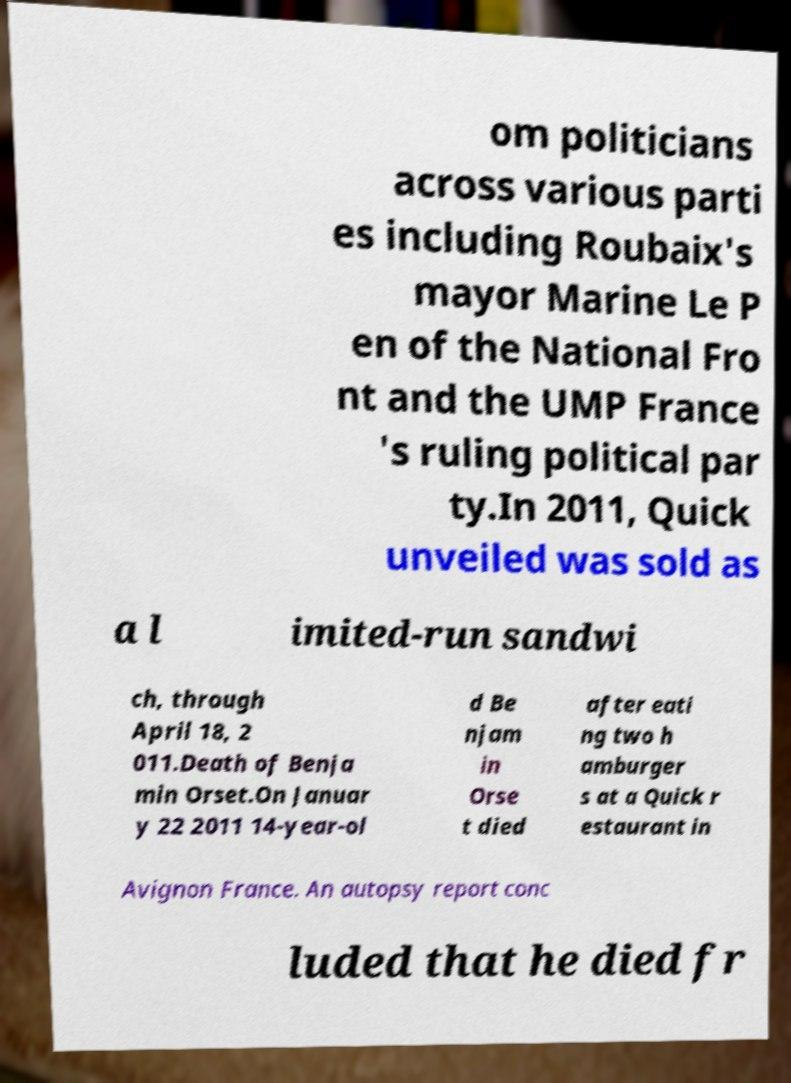Can you accurately transcribe the text from the provided image for me? om politicians across various parti es including Roubaix's mayor Marine Le P en of the National Fro nt and the UMP France 's ruling political par ty.In 2011, Quick unveiled was sold as a l imited-run sandwi ch, through April 18, 2 011.Death of Benja min Orset.On Januar y 22 2011 14-year-ol d Be njam in Orse t died after eati ng two h amburger s at a Quick r estaurant in Avignon France. An autopsy report conc luded that he died fr 